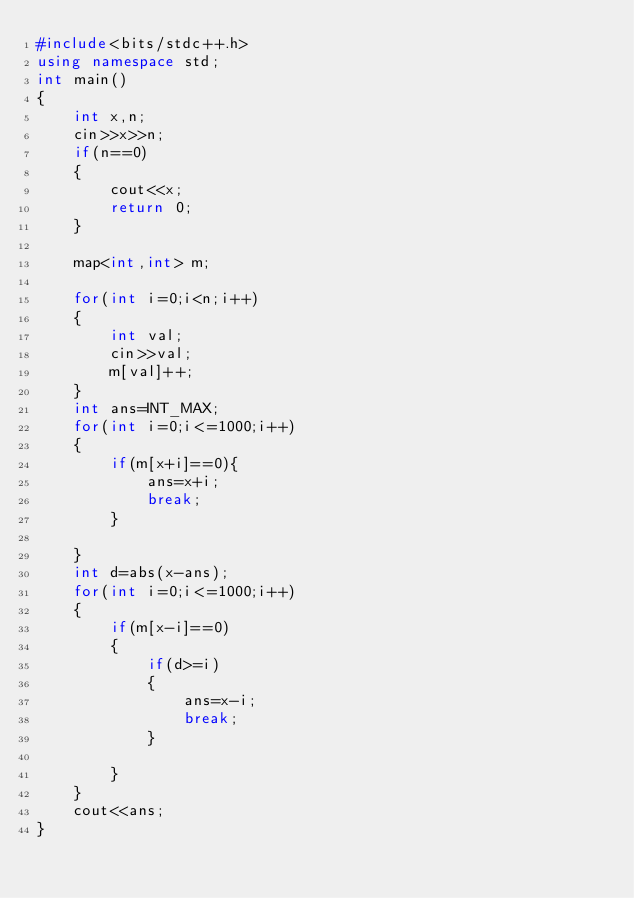Convert code to text. <code><loc_0><loc_0><loc_500><loc_500><_C++_>#include<bits/stdc++.h>
using namespace std;
int main()
{
	int x,n;
	cin>>x>>n;
	if(n==0)
	{
		cout<<x;
		return 0;
	}
	
	map<int,int> m;
	
	for(int i=0;i<n;i++)
	{
		int val;
		cin>>val;
		m[val]++;
	}
	int ans=INT_MAX;
	for(int i=0;i<=1000;i++)
	{
		if(m[x+i]==0){
			ans=x+i;
			break;
		}
		
	}
	int d=abs(x-ans);
	for(int i=0;i<=1000;i++)
	{
		if(m[x-i]==0)
		{
			if(d>=i)
			{
				ans=x-i;
				break;
			}	
			
		}
	}
	cout<<ans;
}</code> 